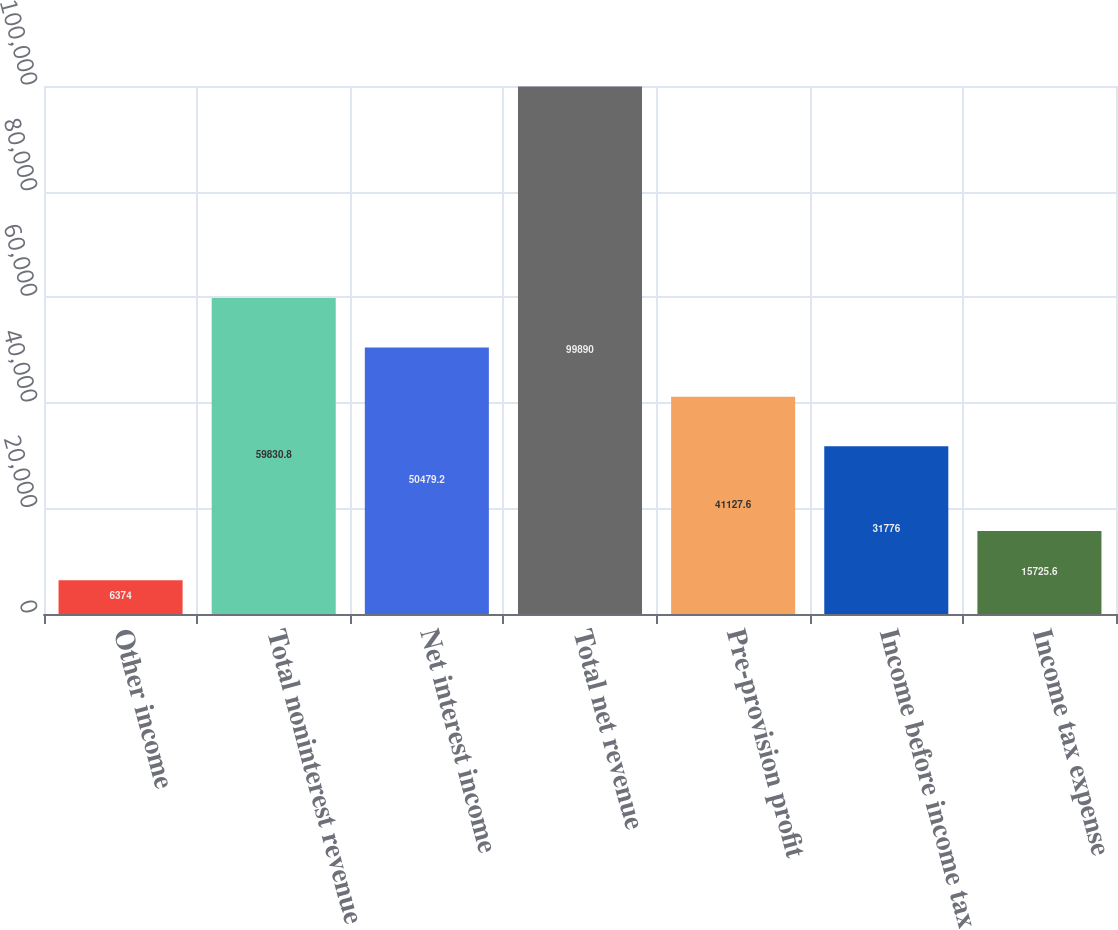Convert chart. <chart><loc_0><loc_0><loc_500><loc_500><bar_chart><fcel>Other income<fcel>Total noninterest revenue<fcel>Net interest income<fcel>Total net revenue<fcel>Pre-provision profit<fcel>Income before income tax<fcel>Income tax expense<nl><fcel>6374<fcel>59830.8<fcel>50479.2<fcel>99890<fcel>41127.6<fcel>31776<fcel>15725.6<nl></chart> 